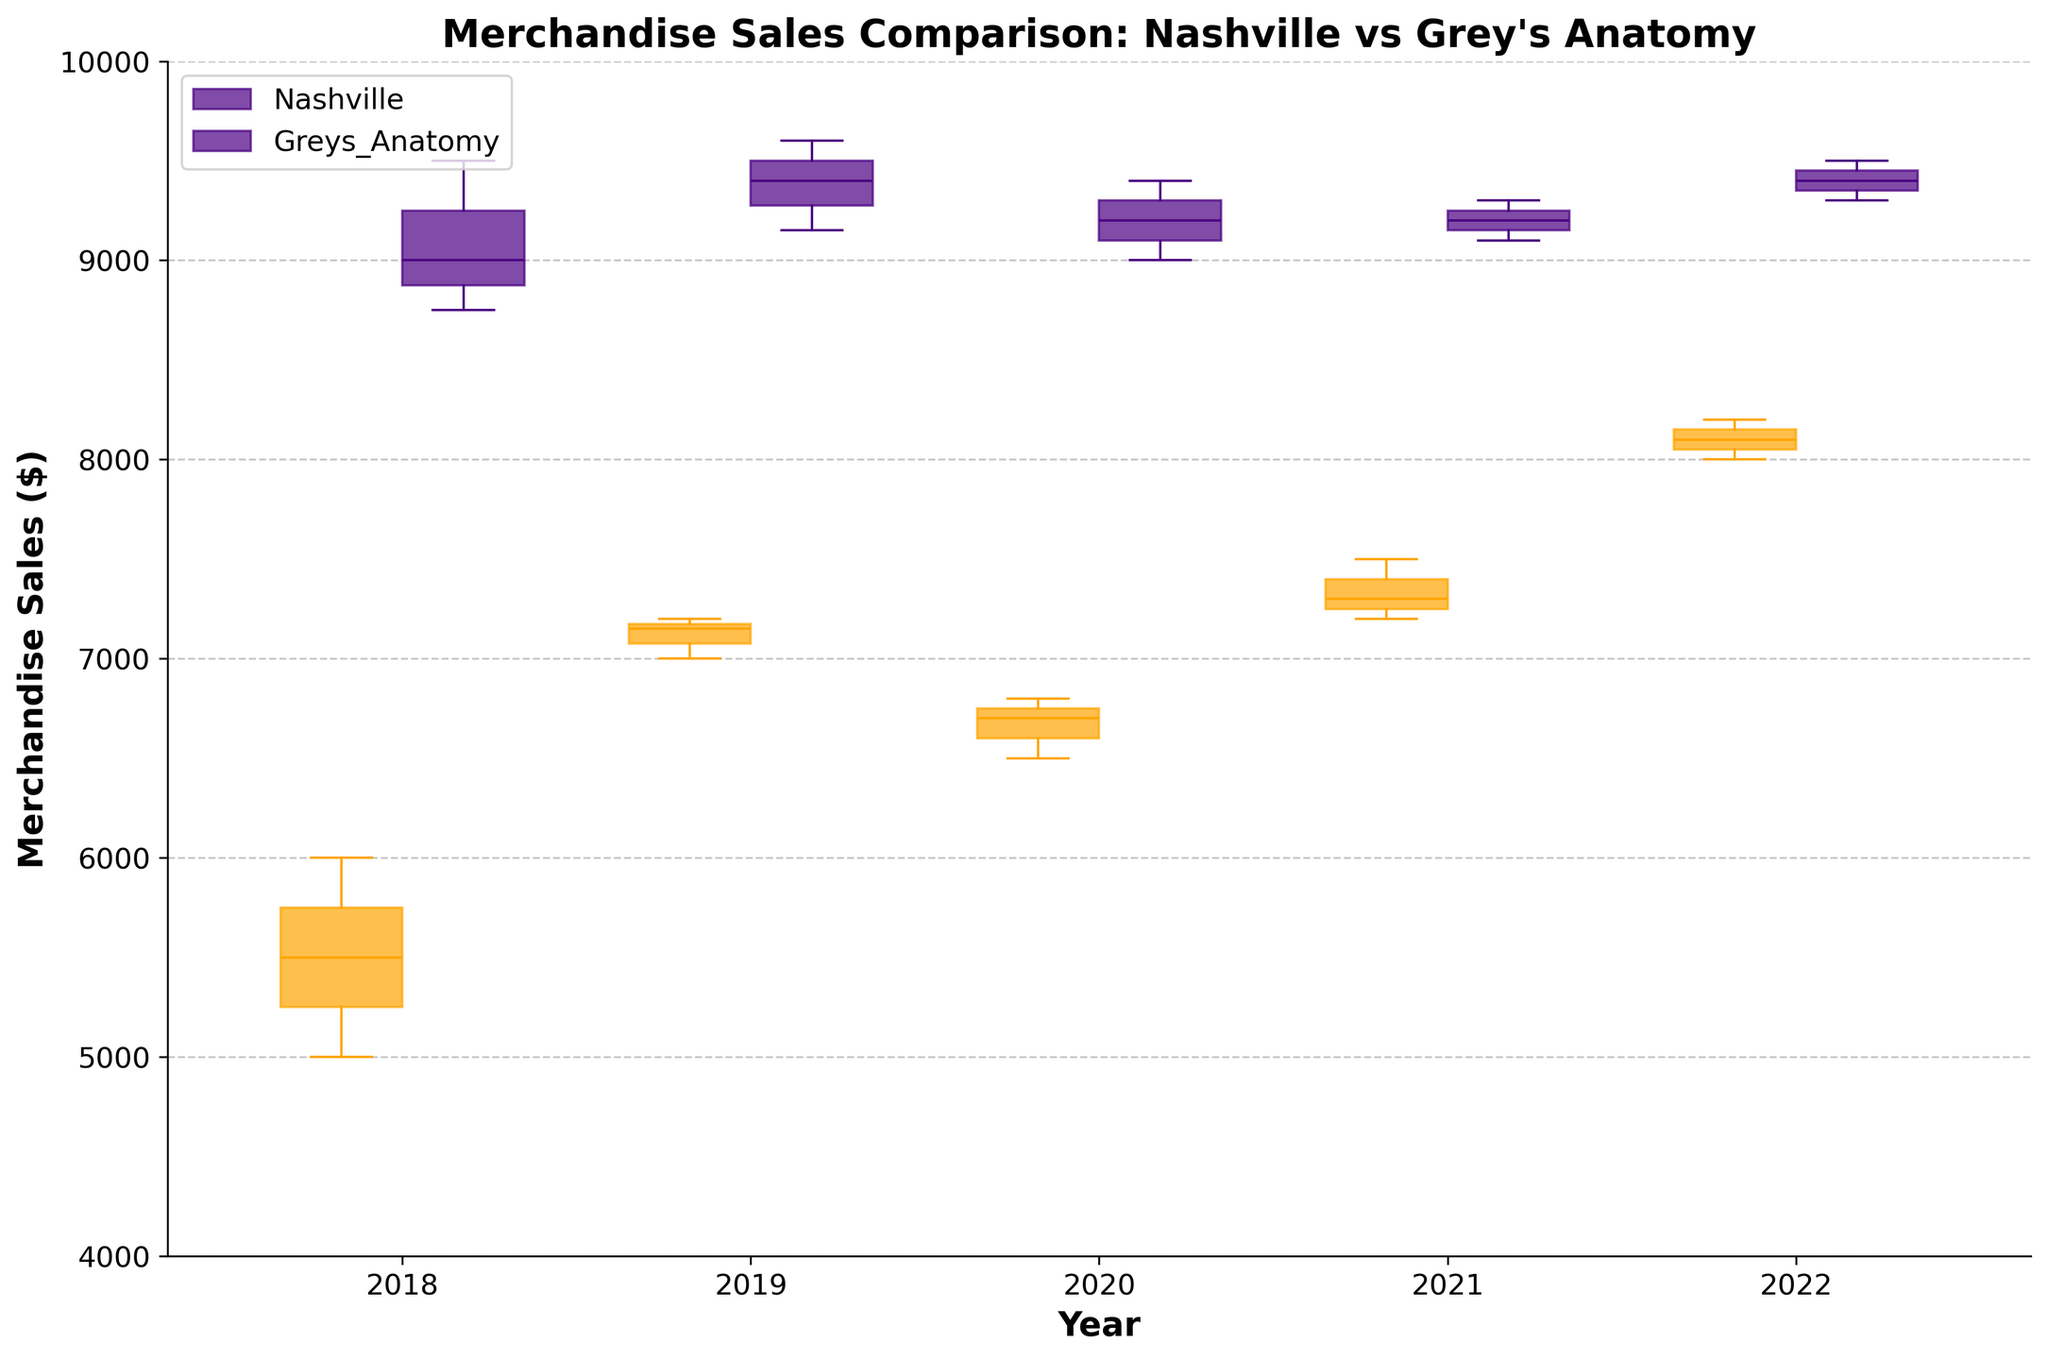What is the title of the plot? The title of the plot is usually found at the top of the figure. Here, the title is clearly marked as "Merchandise Sales Comparison: Nashville vs Grey's Anatomy".
Answer: Merchandise Sales Comparison: Nashville vs Grey's Anatomy What are the colors representing Nashville and Grey's Anatomy fans? The box plot uses two distinct colors to represent each fandom. Nashville fans are represented in orange, and Grey's Anatomy fans are represented in indigo.
Answer: Nashville: orange, Grey's Anatomy: indigo Which year shows the highest median merchandise sales for Nashville fans? By looking at the box plots for Nashville fans (orange) from 2018 to 2022, we identify that the year 2022 has the highest median value, as indicated by the middle line in the box plot.
Answer: 2022 In which year did Grey's Anatomy fans have the lowest range of merchandise sales? The range of the box plot is the distance between the lower and upper whiskers. By visually comparing the lengths of the whiskers of the indigo boxes from 2018 to 2022, Grey's Anatomy fans had the lowest range in 2020.
Answer: 2020 How do the median merchandise sales for Nashville fans in 2019 compare to those in 2020? Observing the median lines (middle lines inside the boxes) for Nashville fans (orange) in 2019 and 2020, we see that the median in 2019 is higher than in 2020.
Answer: 2019 > 2020 What is the general trend of merchandise sales for Nashville fans over the five years according to the box plots? Reviewing the median lines for Nashville fans (orange boxes) from 2018 to 2022, a general increasing trend can be identified, with some fluctuations.
Answer: Increasing trend Compare the variability in merchandise sales between Nashville and Grey's Anatomy fans in 2021. Variability is represented by the interquartile range (IQR) and the length of the whiskers. For 2021, Grey's Anatomy fans (indigo box) show a lower variability compared to Nashville fans (orange box).
Answer: Grey's Anatomy < Nashville In which year were the median merchandise sales for Grey's Anatomy fans closest to 9000? By locating the position of the middle line (median) inside the indigo boxes across years, the year 2018 shows the median closest to 9000 for Grey's Anatomy fans.
Answer: 2018 Which fandom shows a more consistent increase in median merchandise sales over the years? By comparing the middle lines (medians) of the box plots for both Nashville (orange) and Grey's Anatomy (indigo), Nashville fans show a more consistent increase in median sales from 2018 to 2022.
Answer: Nashville 